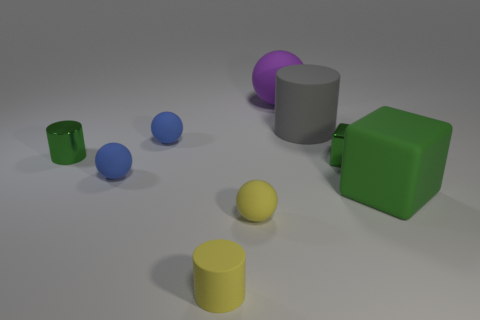There is a small yellow object that is the same shape as the purple thing; what is its material?
Offer a very short reply. Rubber. What size is the purple object left of the green cube that is behind the large green rubber block?
Provide a short and direct response. Large. Is there a large green matte cylinder?
Give a very brief answer. No. There is a ball that is right of the yellow rubber cylinder and to the left of the big purple rubber object; what material is it?
Offer a terse response. Rubber. Is the number of tiny metal things that are on the right side of the green cylinder greater than the number of tiny blue objects that are in front of the yellow cylinder?
Your answer should be compact. Yes. Is there a purple matte sphere of the same size as the yellow ball?
Your answer should be very brief. No. There is a metal thing to the left of the green shiny object that is right of the matte cylinder that is in front of the tiny shiny cylinder; how big is it?
Ensure brevity in your answer.  Small. What color is the tiny matte cylinder?
Your response must be concise. Yellow. Is the number of small objects that are on the left side of the purple matte ball greater than the number of green matte balls?
Offer a terse response. Yes. What number of big gray things are behind the purple matte object?
Give a very brief answer. 0. 